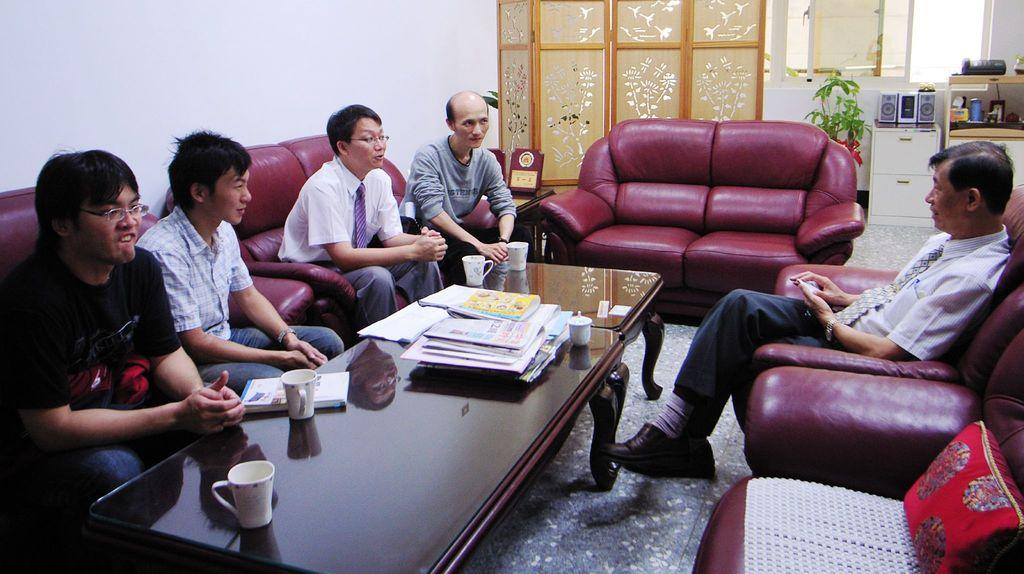What are the people in the image doing? The people in the image are seated. What are the people seated on? The people are seated on chairs. What can be seen on the table in the image? There are cups, papers, and books on the table. Is there any greenery visible in the image? Yes, there is a plant visible in the image. What type of air is being circulated by the crook in the image? There is no crook present in the image, and therefore no air circulation can be observed. Is there any grass visible in the image? No, there is no grass visible in the image; only a plant is present. 